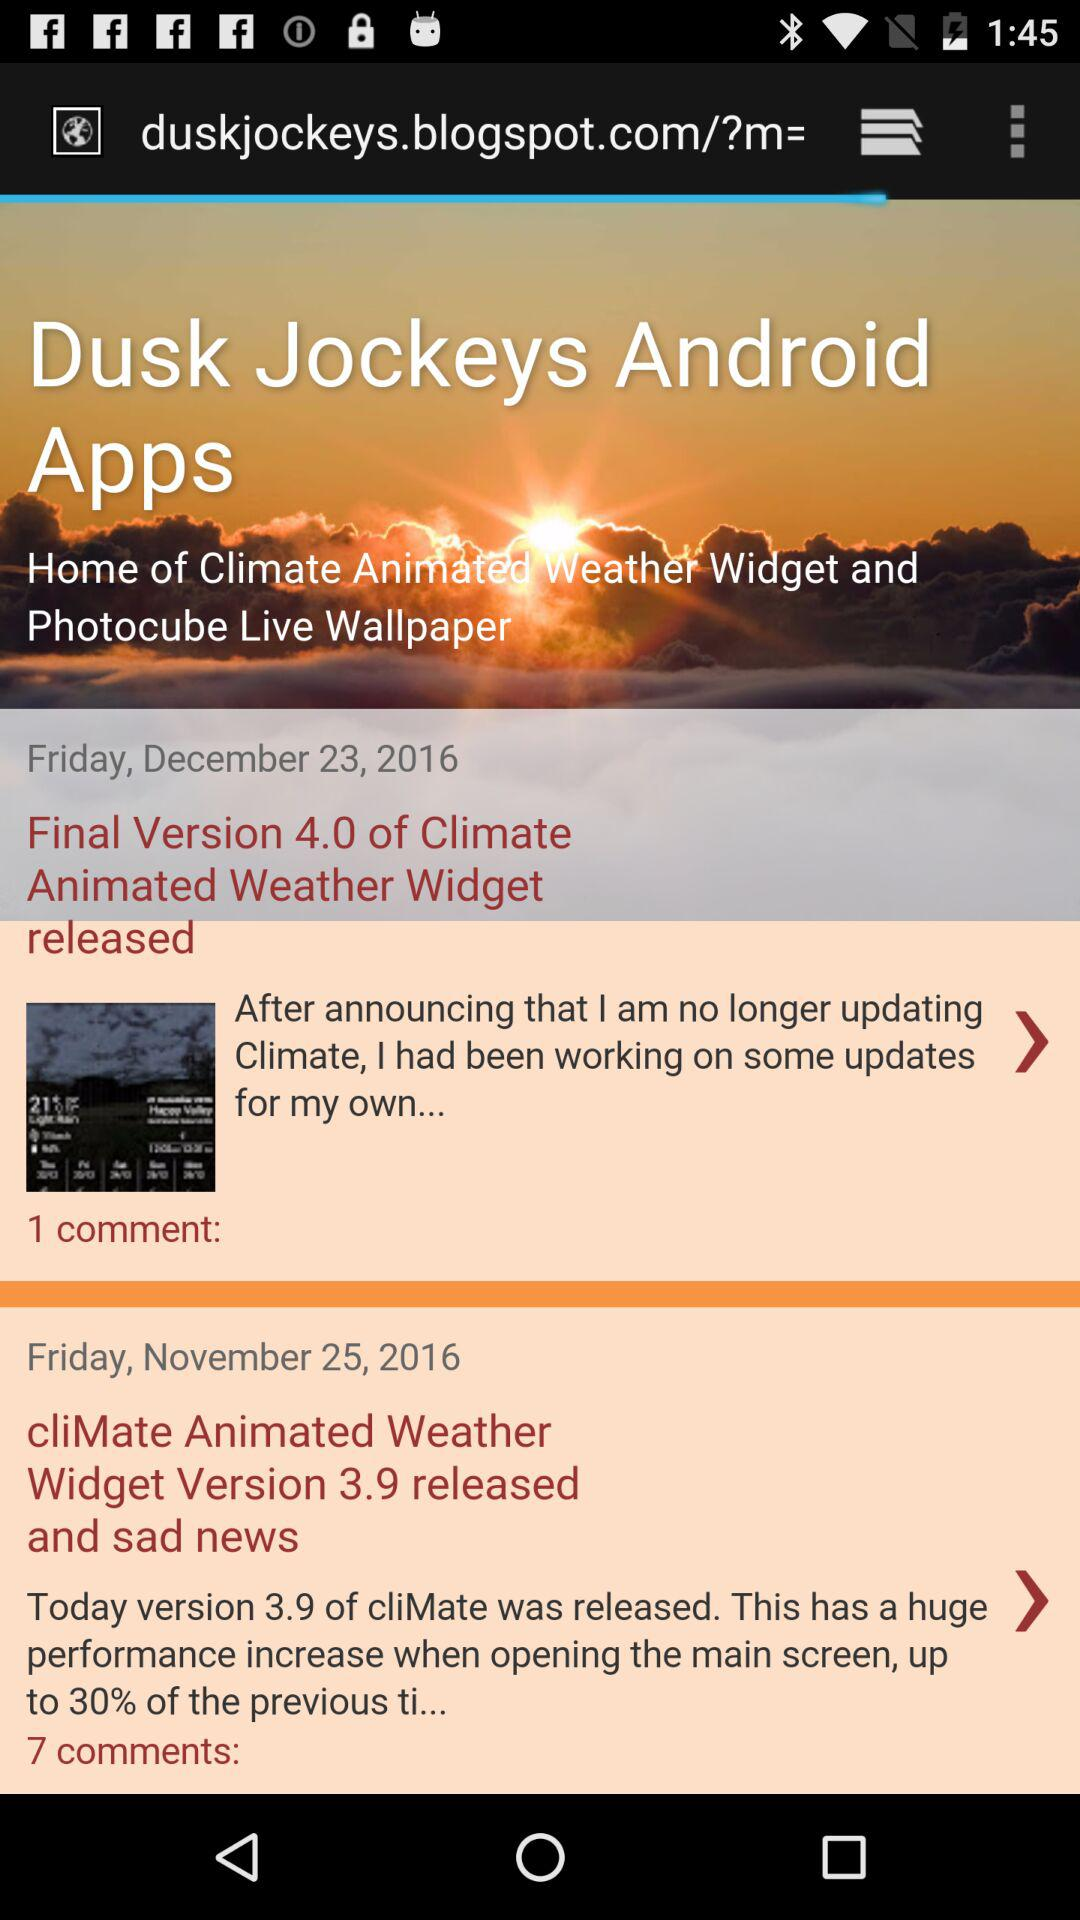At what time was version 4.0 released?
When the provided information is insufficient, respond with <no answer>. <no answer> 